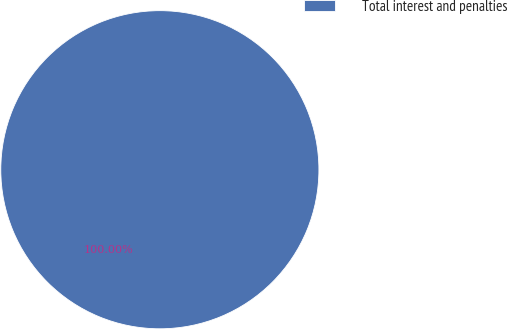<chart> <loc_0><loc_0><loc_500><loc_500><pie_chart><fcel>Total interest and penalties<nl><fcel>100.0%<nl></chart> 